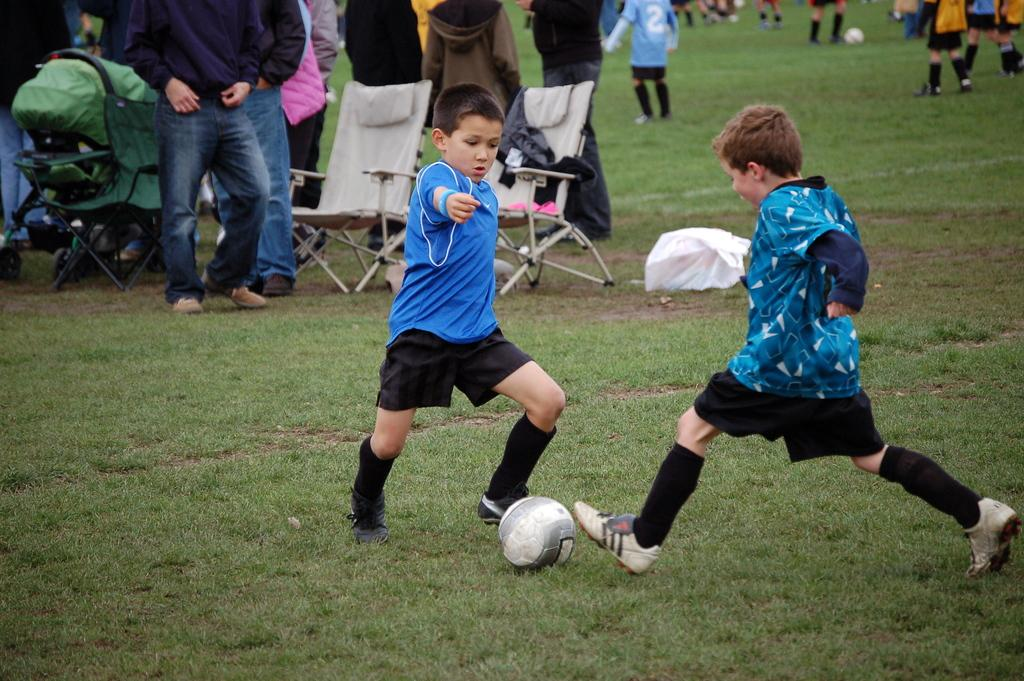How many children are in the image? There are two children in the image. What are the children wearing? The children are wearing black shirts and blue shorts. What activity are the children engaged in? The children are playing with a ball. Where are the children playing? The children are in a grassy area. What can be seen in the background of the image? There are chairs and people standing visible in the background. What type of spoon is being used by the children in the image? There is no spoon present in the image; the children are playing with a ball. Are the children wearing stockings in the image? The provided facts do not mention stockings, but the children are wearing black shirts and blue shorts. 